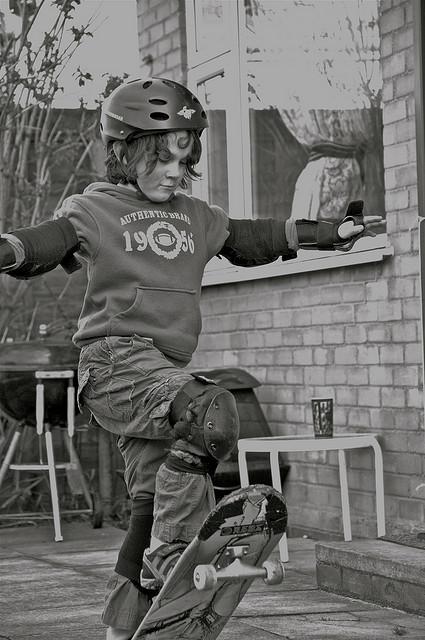What is on the child's knees?
Short answer required. Knee pads. How old is this person?
Short answer required. 10. What does the boys shirt say?
Concise answer only. 1956. What year is printed on the shirt?
Give a very brief answer. 1956. 